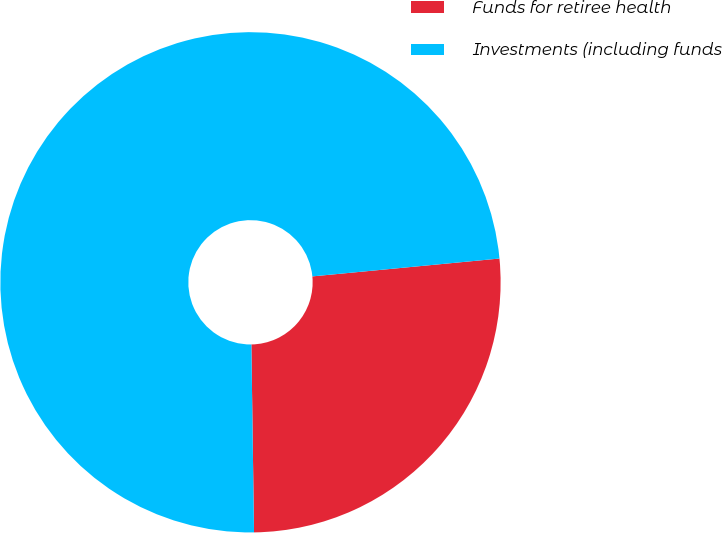<chart> <loc_0><loc_0><loc_500><loc_500><pie_chart><fcel>Funds for retiree health<fcel>Investments (including funds<nl><fcel>26.29%<fcel>73.71%<nl></chart> 